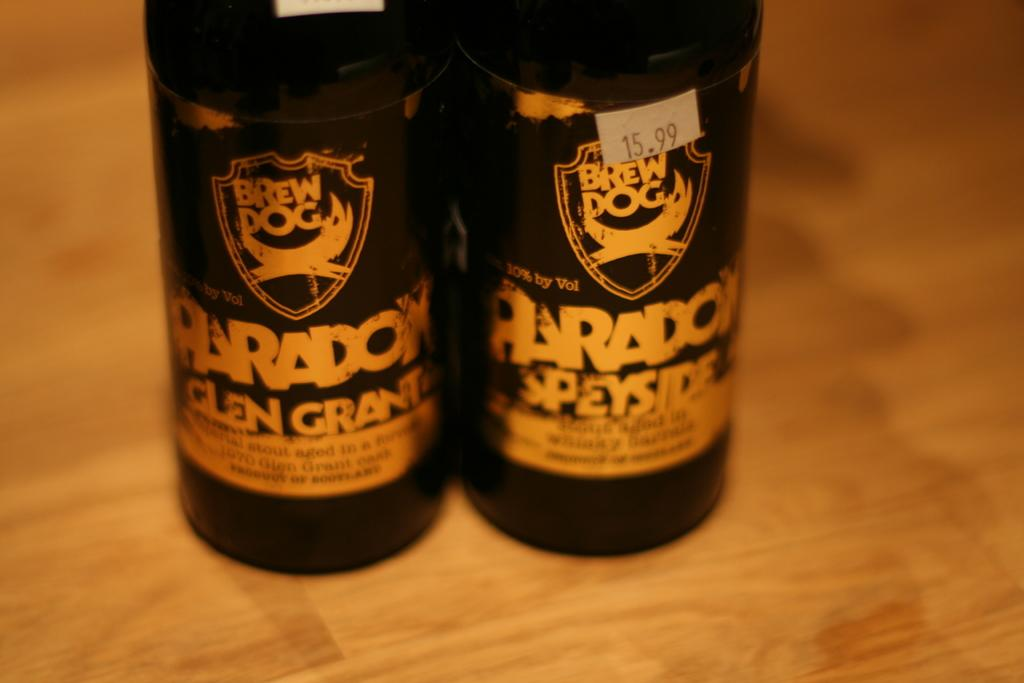<image>
Give a short and clear explanation of the subsequent image. A dark bottle of alcohol named Brew Dog with a yellow and black label. 